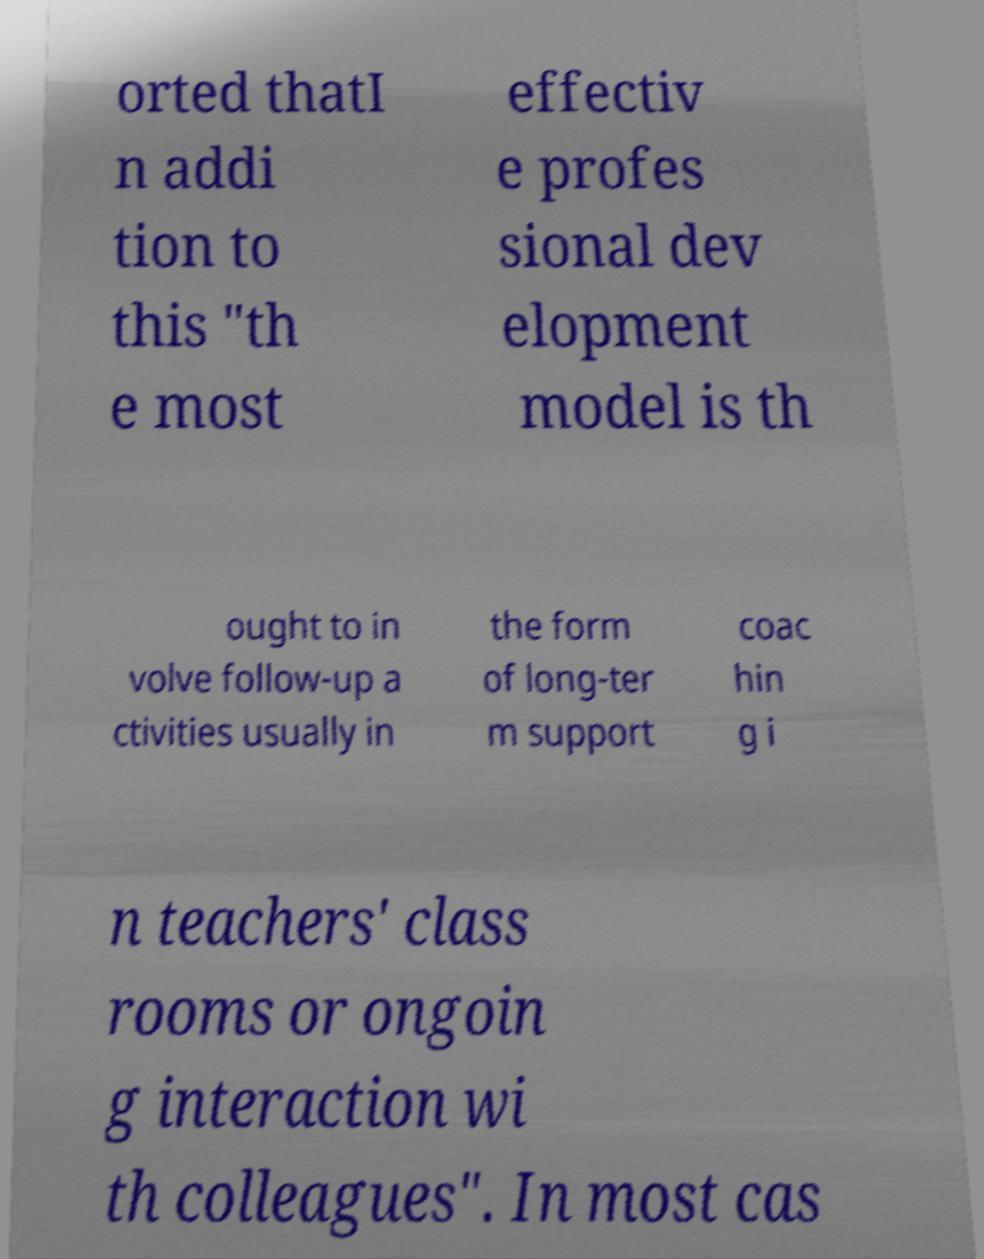For documentation purposes, I need the text within this image transcribed. Could you provide that? orted thatI n addi tion to this "th e most effectiv e profes sional dev elopment model is th ought to in volve follow-up a ctivities usually in the form of long-ter m support coac hin g i n teachers' class rooms or ongoin g interaction wi th colleagues". In most cas 